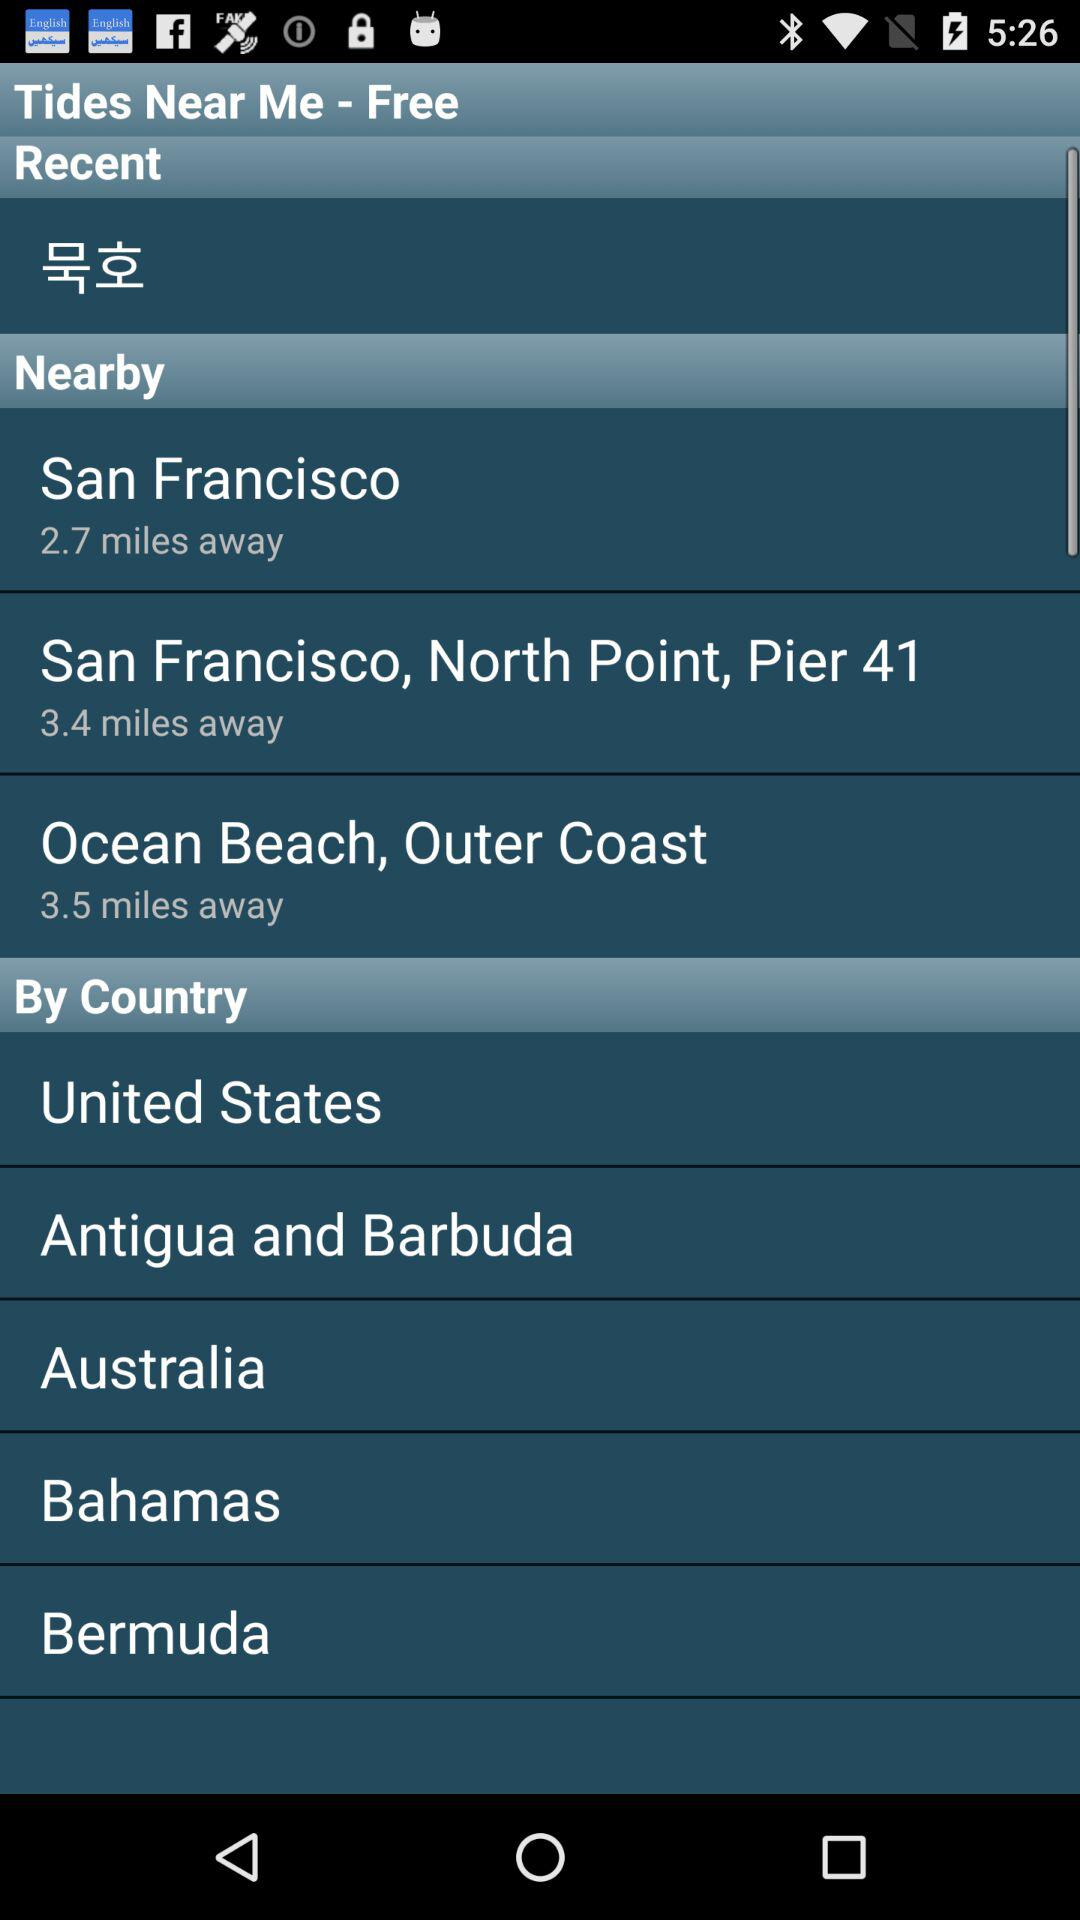What is the name of the application? The name of the application is "Tides Near Me". 